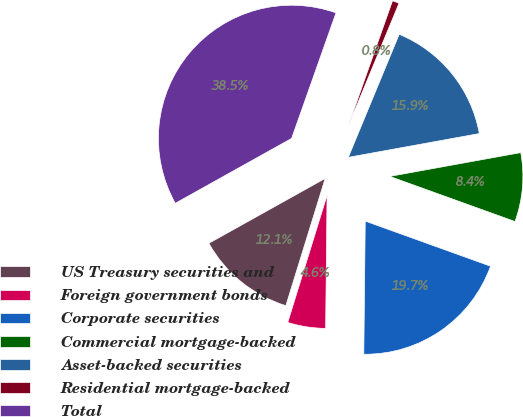<chart> <loc_0><loc_0><loc_500><loc_500><pie_chart><fcel>US Treasury securities and<fcel>Foreign government bonds<fcel>Corporate securities<fcel>Commercial mortgage-backed<fcel>Asset-backed securities<fcel>Residential mortgage-backed<fcel>Total<nl><fcel>12.13%<fcel>4.6%<fcel>19.67%<fcel>8.36%<fcel>15.9%<fcel>0.83%<fcel>38.51%<nl></chart> 